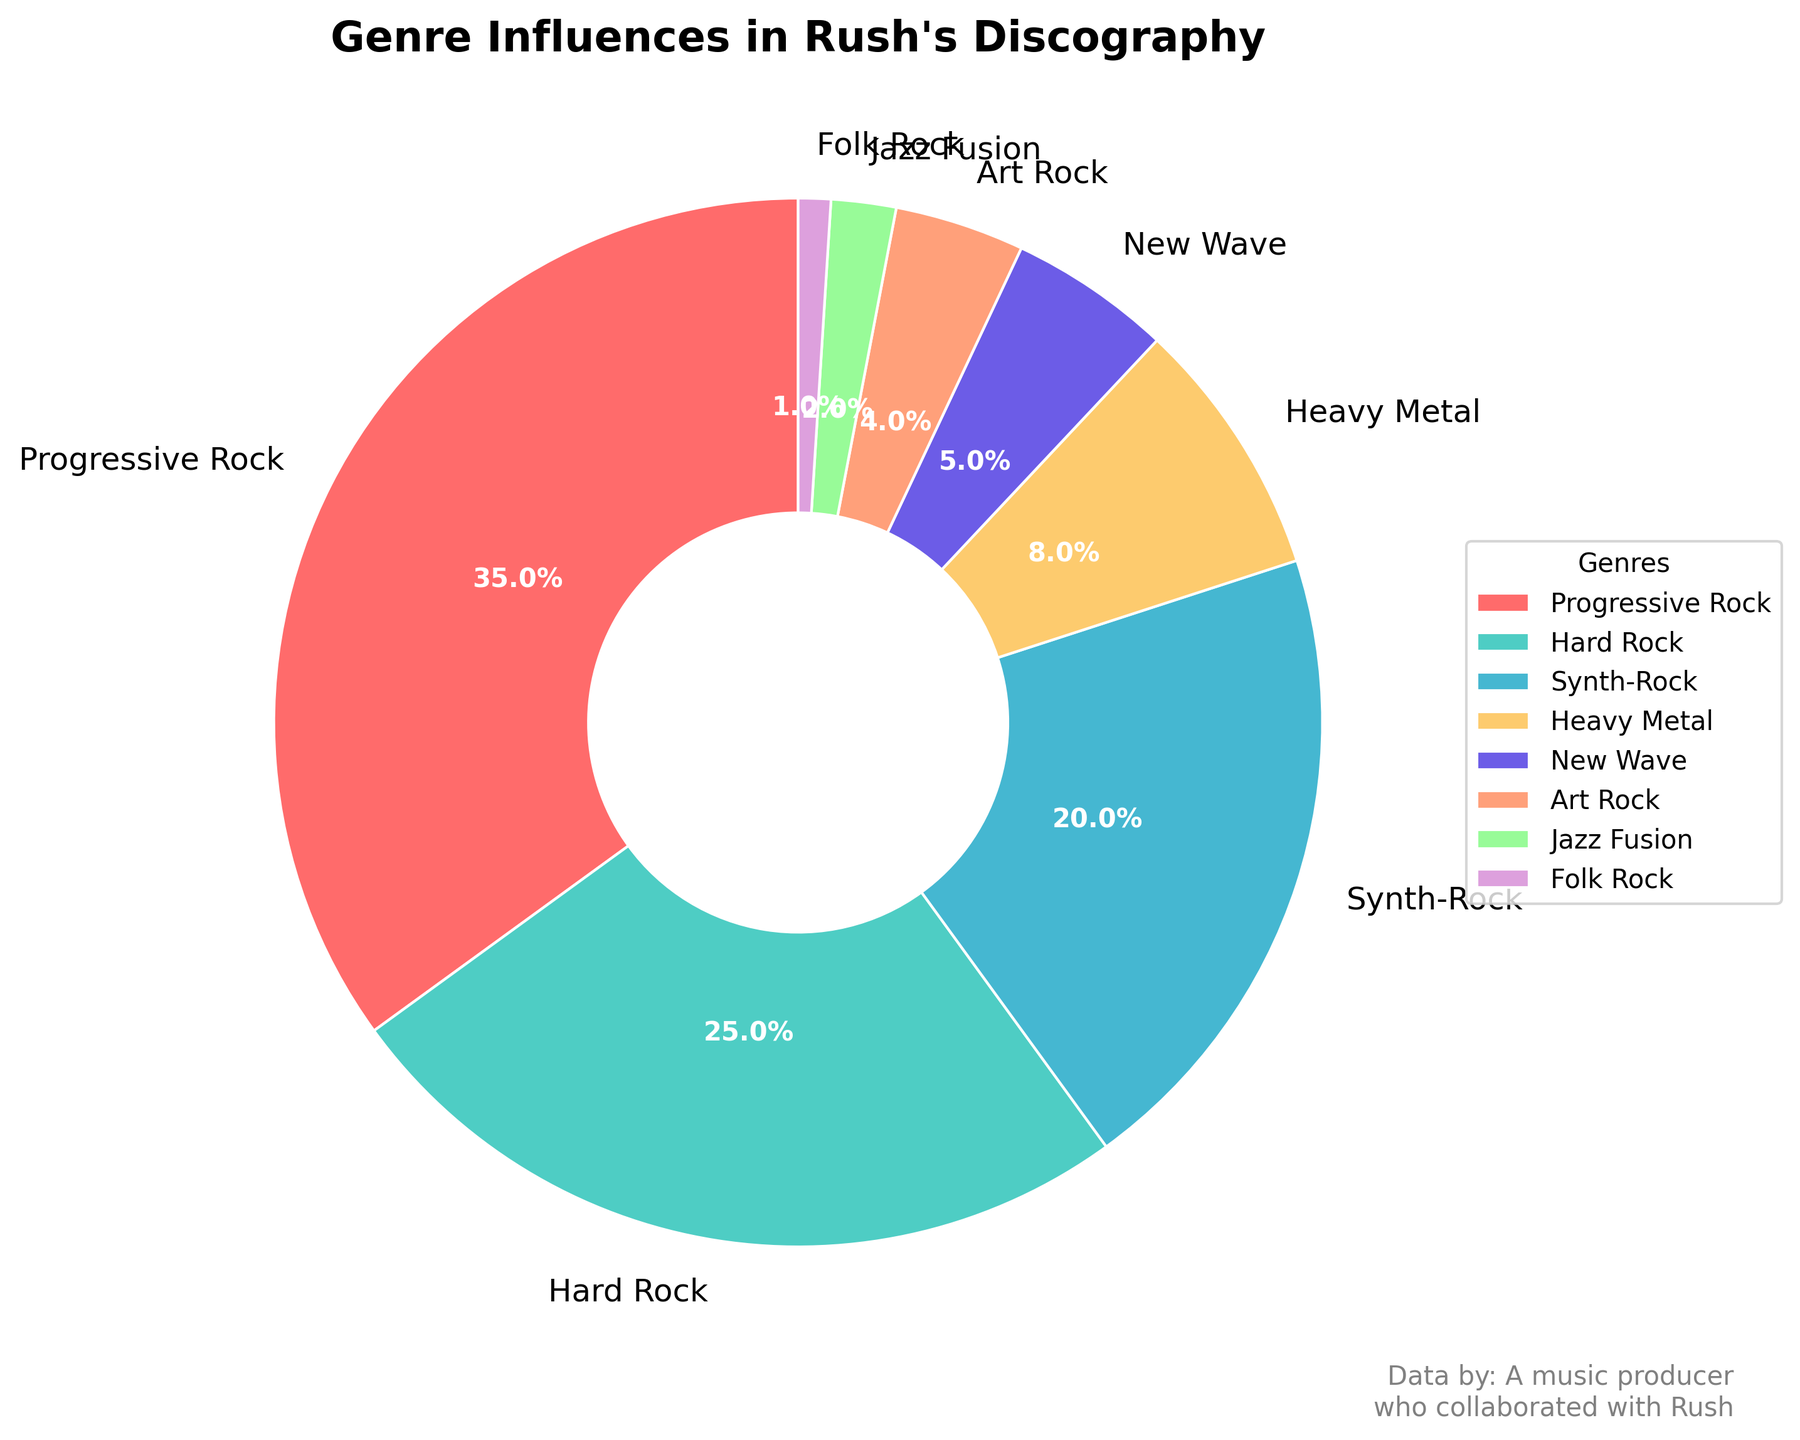What percentage of Rush's discography is influenced by Progressive Rock? Look at the pie chart and find the section labeled Progressive Rock. The percentage indicated for this genre is 35%.
Answer: 35% Which genre has the smallest influence on Rush's discography? Find the smallest wedge in the pie chart. It is labeled Folk Rock with a percentage of 1%, indicating it has the smallest influence.
Answer: Folk Rock How much greater is the influence of Hard Rock compared to New Wave? Find the percentages for Hard Rock (25%) and New Wave (5%), then subtract the New Wave percentage from the Hard Rock percentage: 25% - 5% = 20%.
Answer: 20% What is the combined percentage of the genres with less than 10% influence each? Identify genres with less than 10% influence: Heavy Metal (8%), New Wave (5%), Art Rock (4%), Jazz Fusion (2%), and Folk Rock (1%). Sum these percentages: 8% + 5% + 4% + 2% + 1% = 20%.
Answer: 20% Which genre has a greater influence, Synth-Rock or Heavy Metal, and by how much? Compare the percentages for Synth-Rock (20%) and Heavy Metal (8%). Subtract the Heavy Metal percentage from the Synth-Rock percentage: 20% - 8% = 12%.
Answer: Synth-Rock by 12% What are the two genres following Progressive Rock in terms of influence, and what is their total percentage? Progressive Rock is at 35%. The next two highest percentages are for Hard Rock (25%) and Synth-Rock (20%). Add these percentages: 25% + 20% = 45%.
Answer: Hard Rock and Synth-Rock, 45% If the percentages for Progressive Rock and Hard Rock were combined, what would their total be? Add the percentages for Progressive Rock (35%) and Hard Rock (25%): 35% + 25% = 60%.
Answer: 60% What percentage of Rush's discography is influenced by genres other than Progressive Rock, Hard Rock, and Synth-Rock? Sum the percentages for Progressive Rock, Hard Rock, and Synth-Rock: 35% + 25% + 20% = 80%. Subtract this from 100%: 100% - 80% = 20%.
Answer: 20% Which genre, denoted in a shade of purple, and what is its percentage influence? Identify the wedge in a shade of purple. It represents Art Rock with a percentage of 4%.
Answer: Art Rock, 4% How does the influence of Jazz Fusion compare to New Wave? Locate Jazz Fusion (2%) and New Wave (5%). New Wave has a greater influence. The difference is calculated by subtracting the Jazz Fusion percentage from the New Wave percentage: 5% - 2% = 3%.
Answer: New Wave by 3% 